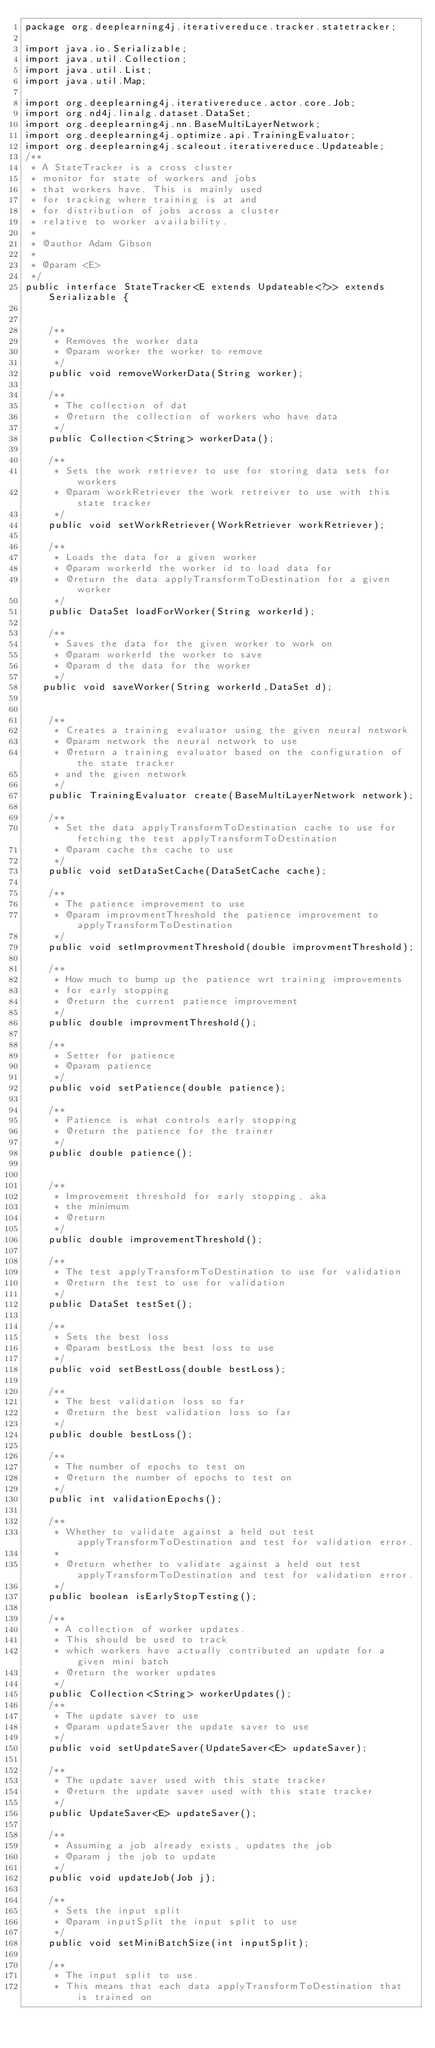<code> <loc_0><loc_0><loc_500><loc_500><_Java_>package org.deeplearning4j.iterativereduce.tracker.statetracker;

import java.io.Serializable;
import java.util.Collection;
import java.util.List;
import java.util.Map;

import org.deeplearning4j.iterativereduce.actor.core.Job;
import org.nd4j.linalg.dataset.DataSet;
import org.deeplearning4j.nn.BaseMultiLayerNetwork;
import org.deeplearning4j.optimize.api.TrainingEvaluator;
import org.deeplearning4j.scaleout.iterativereduce.Updateable;
/**
 * A StateTracker is a cross cluster 
 * monitor for state of workers and jobs
 * that workers have. This is mainly used
 * for tracking where training is at and 
 * for distribution of jobs across a cluster
 * relative to worker availability.
 * 
 * @author Adam Gibson
 *
 * @param <E>
 */
public interface StateTracker<E extends Updateable<?>> extends Serializable {


    /**
     * Removes the worker data
     * @param worker the worker to remove
     */
    public void removeWorkerData(String worker);

    /**
     * The collection of dat
     * @return the collection of workers who have data
     */
    public Collection<String> workerData();

    /**
     * Sets the work retriever to use for storing data sets for workers
     * @param workRetriever the work retreiver to use with this state tracker
     */
    public void setWorkRetriever(WorkRetriever workRetriever);

    /**
     * Loads the data for a given worker
     * @param workerId the worker id to load data for
     * @return the data applyTransformToDestination for a given worker
     */
    public DataSet loadForWorker(String workerId);

    /**
     * Saves the data for the given worker to work on
     * @param workerId the worker to save
     * @param d the data for the worker
     */
   public void saveWorker(String workerId,DataSet d);


    /**
     * Creates a training evaluator using the given neural network
     * @param network the neural network to use
     * @return a training evaluator based on the configuration of the state tracker
     * and the given network
     */
    public TrainingEvaluator create(BaseMultiLayerNetwork network);

    /**
     * Set the data applyTransformToDestination cache to use for fetching the test applyTransformToDestination
     * @param cache the cache to use
     */
    public void setDataSetCache(DataSetCache cache);

    /**
     * The patience improvement to use
     * @param improvmentThreshold the patience improvement to applyTransformToDestination
     */
    public void setImprovmentThreshold(double improvmentThreshold);

    /**
     * How much to bump up the patience wrt training improvements
     * for early stopping
     * @return the current patience improvement
     */
    public double improvmentThreshold();

    /**
     * Setter for patience
     * @param patience
     */
    public void setPatience(double patience);

    /**
     * Patience is what controls early stopping
     * @return the patience for the trainer
     */
    public double patience();


    /**
     * Improvement threshold for early stopping, aka
     * the minimum
     * @return
     */
    public double improvementThreshold();

    /**
     * The test applyTransformToDestination to use for validation
     * @return the test to use for validation
     */
    public DataSet testSet();

    /**
     * Sets the best loss
     * @param bestLoss the best loss to use
     */
    public void setBestLoss(double bestLoss);

    /**
     * The best validation loss so far
     * @return the best validation loss so far
     */
    public double bestLoss();

    /**
     * The number of epochs to test on
     * @return the number of epochs to test on
     */
    public int validationEpochs();

    /**
     * Whether to validate against a held out test applyTransformToDestination and test for validation error.
     *
     * @return whether to validate against a held out test applyTransformToDestination and test for validation error.
     */
    public boolean isEarlyStopTesting();

    /**
     * A collection of worker updates.
     * This should be used to track
     * which workers have actually contributed an update for a given mini batch
     * @return the worker updates
     */
    public Collection<String> workerUpdates();
    /**
     * The update saver to use
     * @param updateSaver the update saver to use
     */
    public void setUpdateSaver(UpdateSaver<E> updateSaver);

    /**
     * The update saver used with this state tracker
     * @return the update saver used with this state tracker
     */
    public UpdateSaver<E> updateSaver();

    /**
     * Assuming a job already exists, updates the job
     * @param j the job to update
     */
    public void updateJob(Job j);

    /**
     * Sets the input split
     * @param inputSplit the input split to use
     */
    public void setMiniBatchSize(int inputSplit);

    /**
     * The input split to use.
     * This means that each data applyTransformToDestination that is trained on</code> 